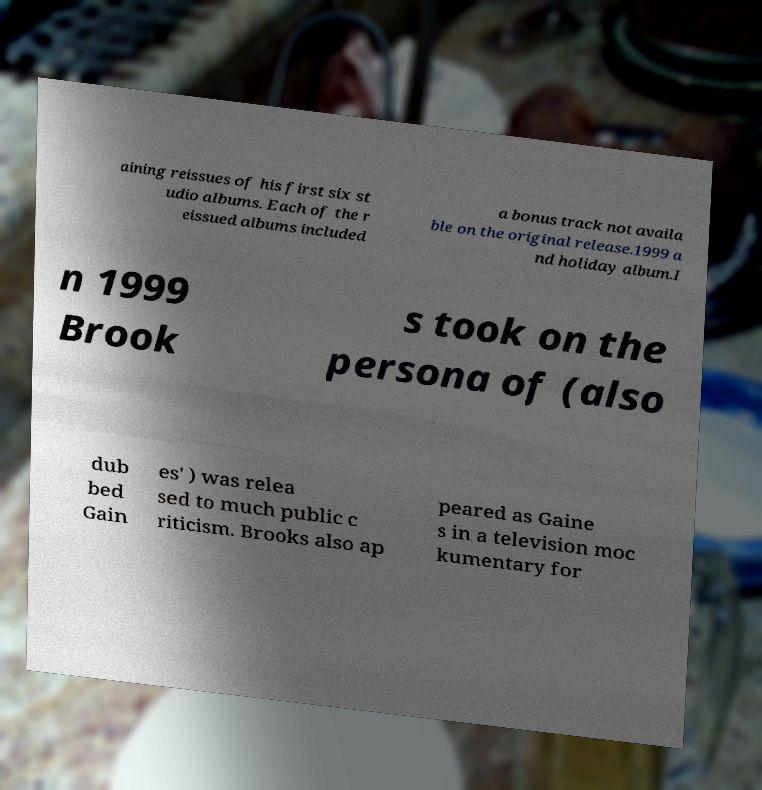Please read and relay the text visible in this image. What does it say? aining reissues of his first six st udio albums. Each of the r eissued albums included a bonus track not availa ble on the original release.1999 a nd holiday album.I n 1999 Brook s took on the persona of (also dub bed Gain es' ) was relea sed to much public c riticism. Brooks also ap peared as Gaine s in a television moc kumentary for 